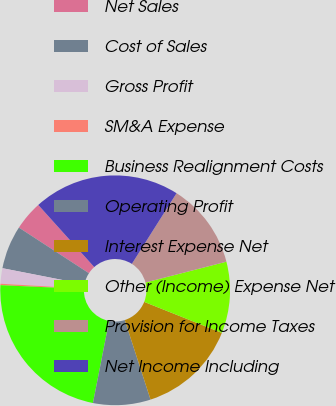Convert chart to OTSL. <chart><loc_0><loc_0><loc_500><loc_500><pie_chart><fcel>Net Sales<fcel>Cost of Sales<fcel>Gross Profit<fcel>SM&A Expense<fcel>Business Realignment Costs<fcel>Operating Profit<fcel>Interest Expense Net<fcel>Other (Income) Expense Net<fcel>Provision for Income Taxes<fcel>Net Income Including<nl><fcel>4.14%<fcel>6.11%<fcel>2.17%<fcel>0.2%<fcel>22.62%<fcel>8.08%<fcel>13.98%<fcel>10.05%<fcel>12.02%<fcel>20.65%<nl></chart> 